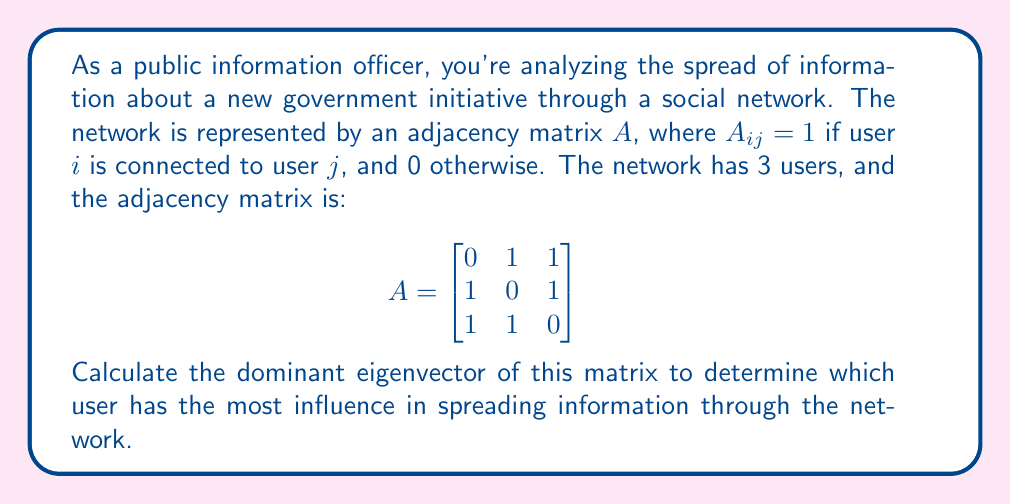Solve this math problem. To find the dominant eigenvector, we'll use the power iteration method:

1) Start with a random vector $v_0 = [1, 1, 1]^T$

2) Iterate using the formula $v_{k+1} = \frac{Av_k}{\|Av_k\|}$ until convergence

3) First iteration:
   $Av_0 = \begin{bmatrix}
   0 & 1 & 1 \\
   1 & 0 & 1 \\
   1 & 1 & 0
   \end{bmatrix} \begin{bmatrix} 1 \\ 1 \\ 1 \end{bmatrix} = \begin{bmatrix} 2 \\ 2 \\ 2 \end{bmatrix}$

   $v_1 = \frac{1}{\sqrt{2^2 + 2^2 + 2^2}} \begin{bmatrix} 2 \\ 2 \\ 2 \end{bmatrix} = \begin{bmatrix} 0.5774 \\ 0.5774 \\ 0.5774 \end{bmatrix}$

4) Second iteration:
   $Av_1 = \begin{bmatrix}
   0 & 1 & 1 \\
   1 & 0 & 1 \\
   1 & 1 & 0
   \end{bmatrix} \begin{bmatrix} 0.5774 \\ 0.5774 \\ 0.5774 \end{bmatrix} = \begin{bmatrix} 1.1548 \\ 1.1548 \\ 1.1548 \end{bmatrix}$

   $v_2 = \frac{1}{\sqrt{1.1548^2 + 1.1548^2 + 1.1548^2}} \begin{bmatrix} 1.1548 \\ 1.1548 \\ 1.1548 \end{bmatrix} = \begin{bmatrix} 0.5774 \\ 0.5774 \\ 0.5774 \end{bmatrix}$

5) The vector has converged, so this is our dominant eigenvector.

The eigenvector $[0.5774, 0.5774, 0.5774]^T$ shows that all users have equal influence in this network.
Answer: $[0.5774, 0.5774, 0.5774]^T$ 